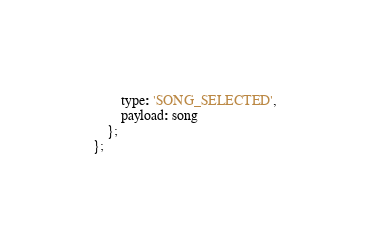<code> <loc_0><loc_0><loc_500><loc_500><_JavaScript_>        type: 'SONG_SELECTED',
        payload: song
    };
};
</code> 